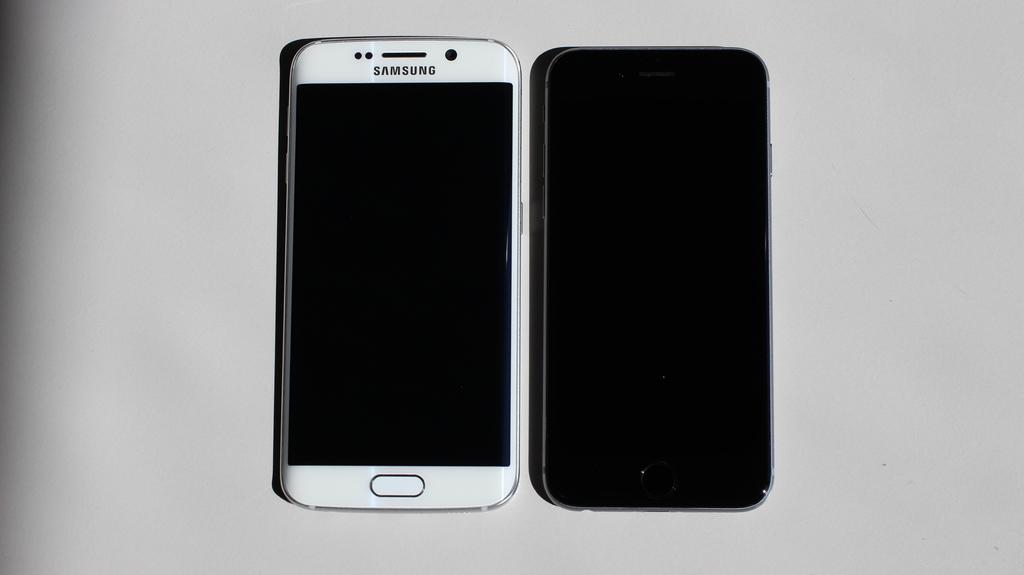<image>
Write a terse but informative summary of the picture. The front and back view of a black and white Samsung cellphone 